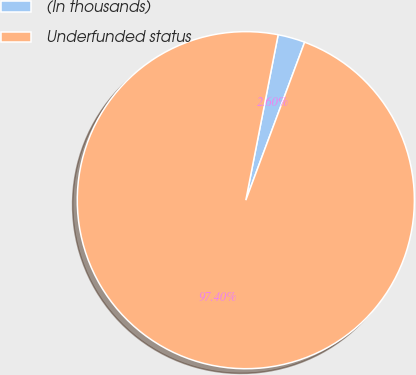Convert chart. <chart><loc_0><loc_0><loc_500><loc_500><pie_chart><fcel>(In thousands)<fcel>Underfunded status<nl><fcel>2.6%<fcel>97.4%<nl></chart> 